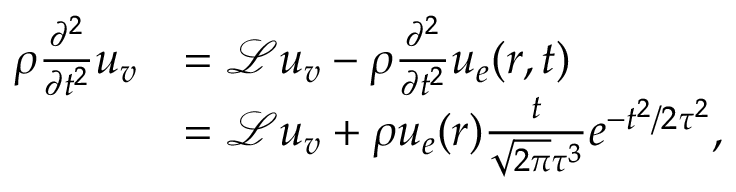<formula> <loc_0><loc_0><loc_500><loc_500>\begin{array} { r l } { \rho \frac { \partial ^ { 2 } } { \partial t ^ { 2 } } u _ { v } } & { = \mathcal { L } u _ { v } - \rho \frac { \partial ^ { 2 } } { \partial t ^ { 2 } } u _ { e } ( r , t ) } \\ & { = \mathcal { L } u _ { v } + \rho u _ { e } ( r ) \frac { t } { \sqrt { 2 \pi } \tau ^ { 3 } } e ^ { - t ^ { 2 } / { 2 \tau ^ { 2 } } } , } \end{array}</formula> 